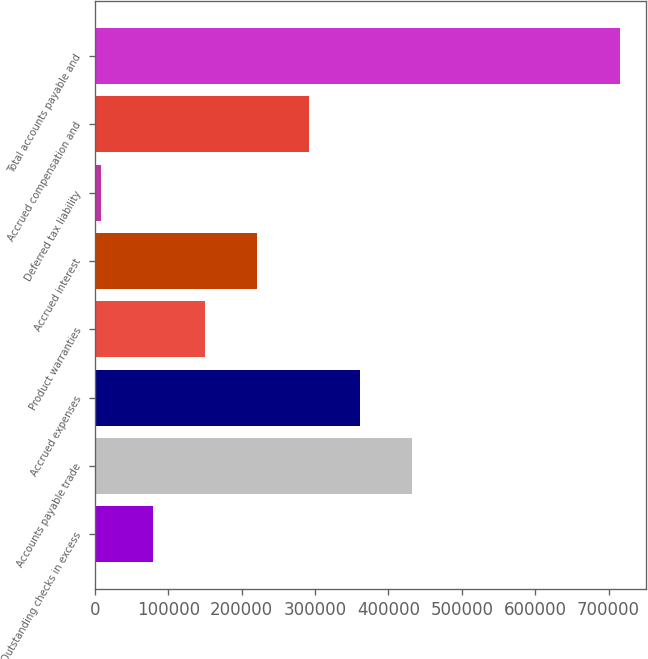Convert chart. <chart><loc_0><loc_0><loc_500><loc_500><bar_chart><fcel>Outstanding checks in excess<fcel>Accounts payable trade<fcel>Accrued expenses<fcel>Product warranties<fcel>Accrued interest<fcel>Deferred tax liability<fcel>Accrued compensation and<fcel>Total accounts payable and<nl><fcel>79393.1<fcel>432559<fcel>361926<fcel>150026<fcel>220659<fcel>8760<fcel>291292<fcel>715091<nl></chart> 